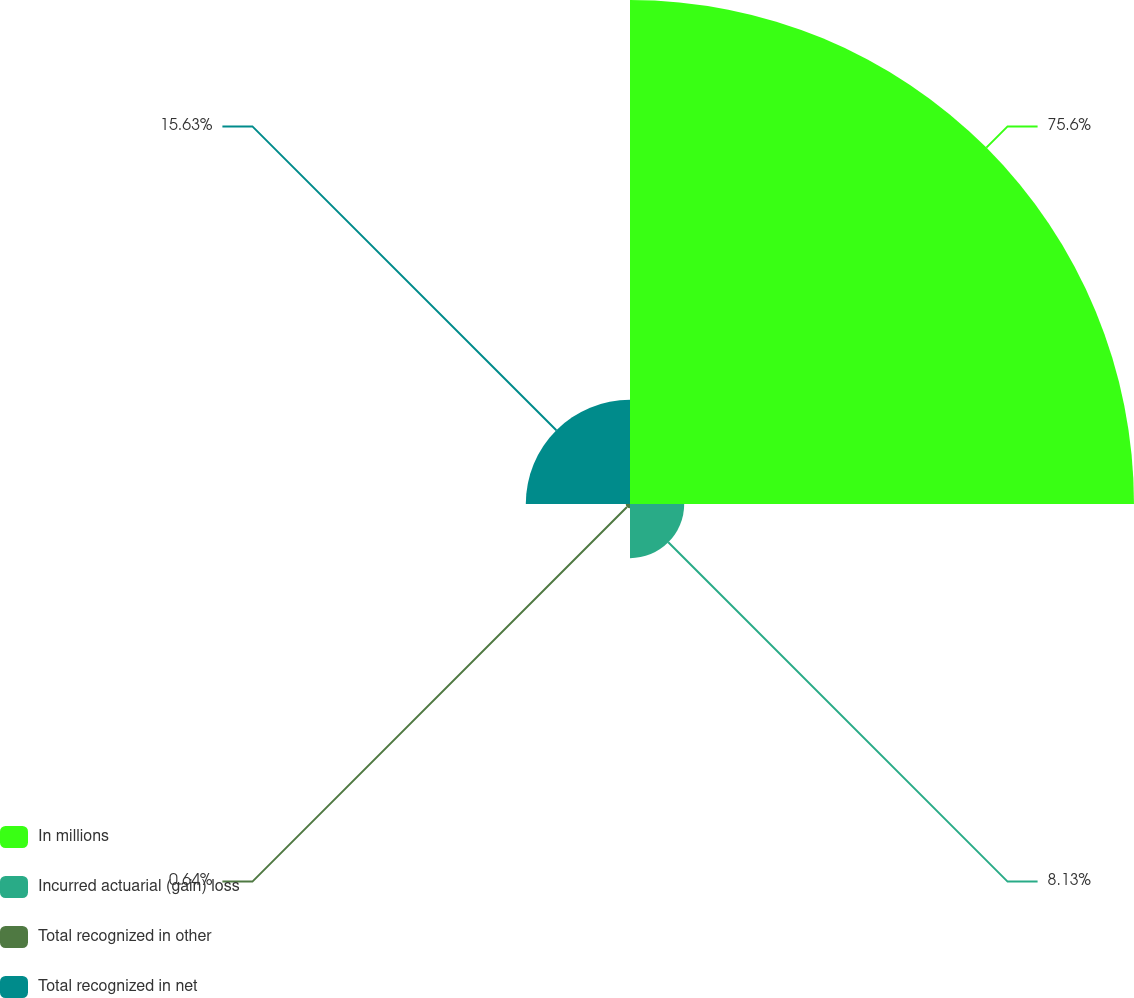Convert chart. <chart><loc_0><loc_0><loc_500><loc_500><pie_chart><fcel>In millions<fcel>Incurred actuarial (gain) loss<fcel>Total recognized in other<fcel>Total recognized in net<nl><fcel>75.6%<fcel>8.13%<fcel>0.64%<fcel>15.63%<nl></chart> 